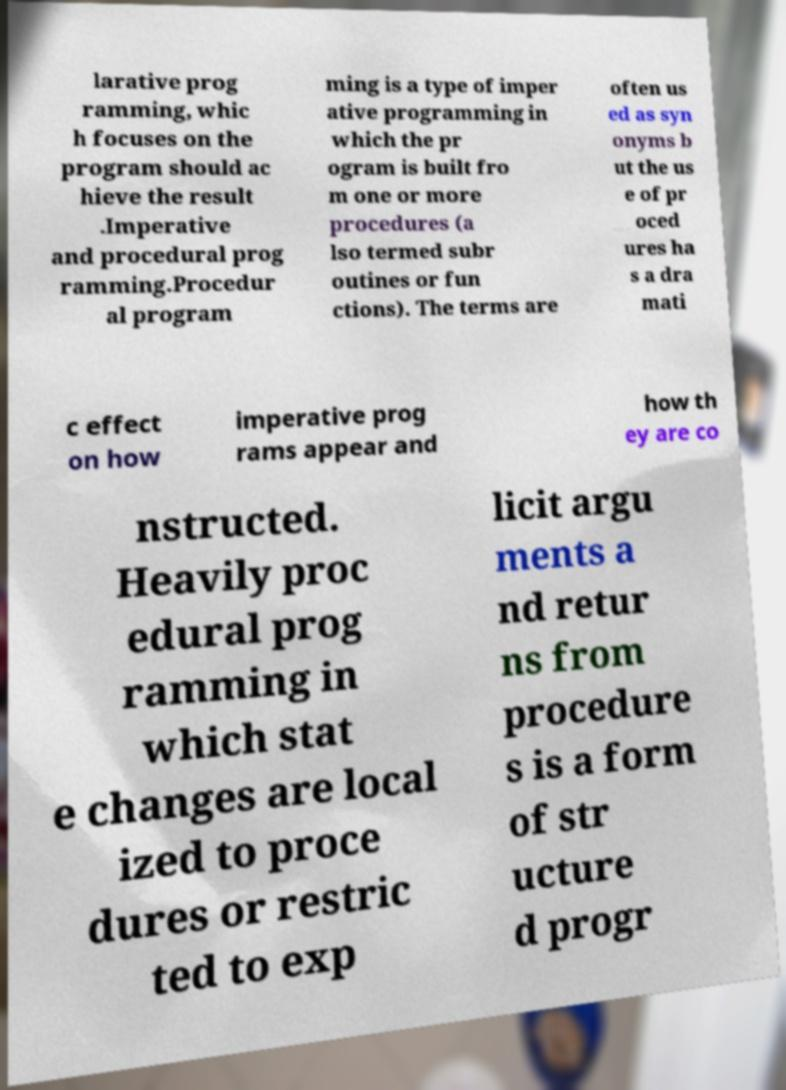What messages or text are displayed in this image? I need them in a readable, typed format. larative prog ramming, whic h focuses on the program should ac hieve the result .Imperative and procedural prog ramming.Procedur al program ming is a type of imper ative programming in which the pr ogram is built fro m one or more procedures (a lso termed subr outines or fun ctions). The terms are often us ed as syn onyms b ut the us e of pr oced ures ha s a dra mati c effect on how imperative prog rams appear and how th ey are co nstructed. Heavily proc edural prog ramming in which stat e changes are local ized to proce dures or restric ted to exp licit argu ments a nd retur ns from procedure s is a form of str ucture d progr 